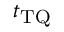Convert formula to latex. <formula><loc_0><loc_0><loc_500><loc_500>t _ { T Q }</formula> 